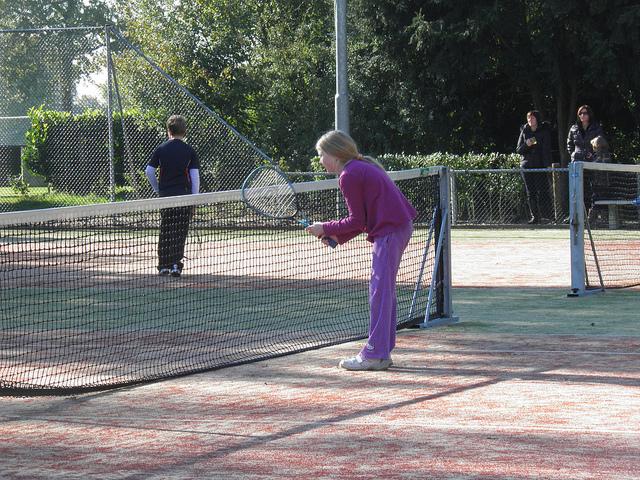Is the girl taller than the net?
Write a very short answer. Yes. Is the girl waiting for the ball?
Quick response, please. Yes. How many people are in this scene?
Be succinct. 4. 